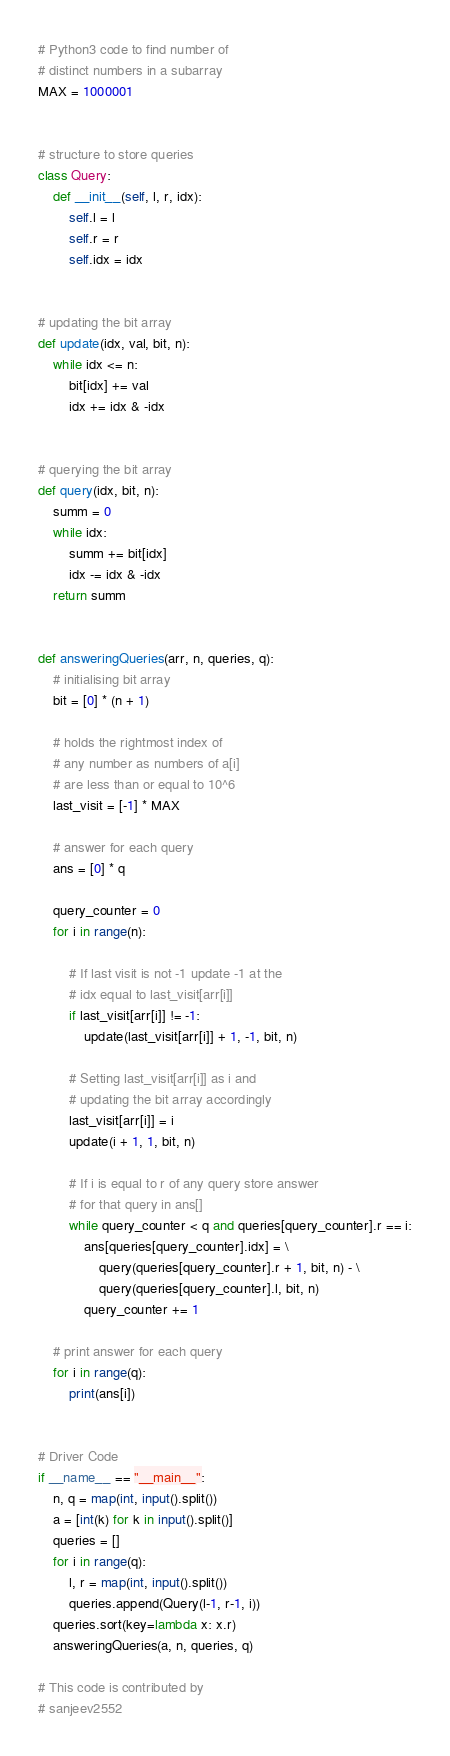Convert code to text. <code><loc_0><loc_0><loc_500><loc_500><_Python_># Python3 code to find number of
# distinct numbers in a subarray
MAX = 1000001


# structure to store queries
class Query:
    def __init__(self, l, r, idx):
        self.l = l
        self.r = r
        self.idx = idx


# updating the bit array
def update(idx, val, bit, n):
    while idx <= n:
        bit[idx] += val
        idx += idx & -idx


# querying the bit array
def query(idx, bit, n):
    summ = 0
    while idx:
        summ += bit[idx]
        idx -= idx & -idx
    return summ


def answeringQueries(arr, n, queries, q):
    # initialising bit array
    bit = [0] * (n + 1)

    # holds the rightmost index of
    # any number as numbers of a[i]
    # are less than or equal to 10^6
    last_visit = [-1] * MAX

    # answer for each query
    ans = [0] * q

    query_counter = 0
    for i in range(n):

        # If last visit is not -1 update -1 at the
        # idx equal to last_visit[arr[i]]
        if last_visit[arr[i]] != -1:
            update(last_visit[arr[i]] + 1, -1, bit, n)

        # Setting last_visit[arr[i]] as i and
        # updating the bit array accordingly
        last_visit[arr[i]] = i
        update(i + 1, 1, bit, n)

        # If i is equal to r of any query store answer
        # for that query in ans[]
        while query_counter < q and queries[query_counter].r == i:
            ans[queries[query_counter].idx] = \
                query(queries[query_counter].r + 1, bit, n) - \
                query(queries[query_counter].l, bit, n)
            query_counter += 1

    # print answer for each query
    for i in range(q):
        print(ans[i])


# Driver Code
if __name__ == "__main__":
    n, q = map(int, input().split())
    a = [int(k) for k in input().split()]
    queries = []
    for i in range(q):
        l, r = map(int, input().split())
        queries.append(Query(l-1, r-1, i))
    queries.sort(key=lambda x: x.r)
    answeringQueries(a, n, queries, q)

# This code is contributed by
# sanjeev2552
</code> 